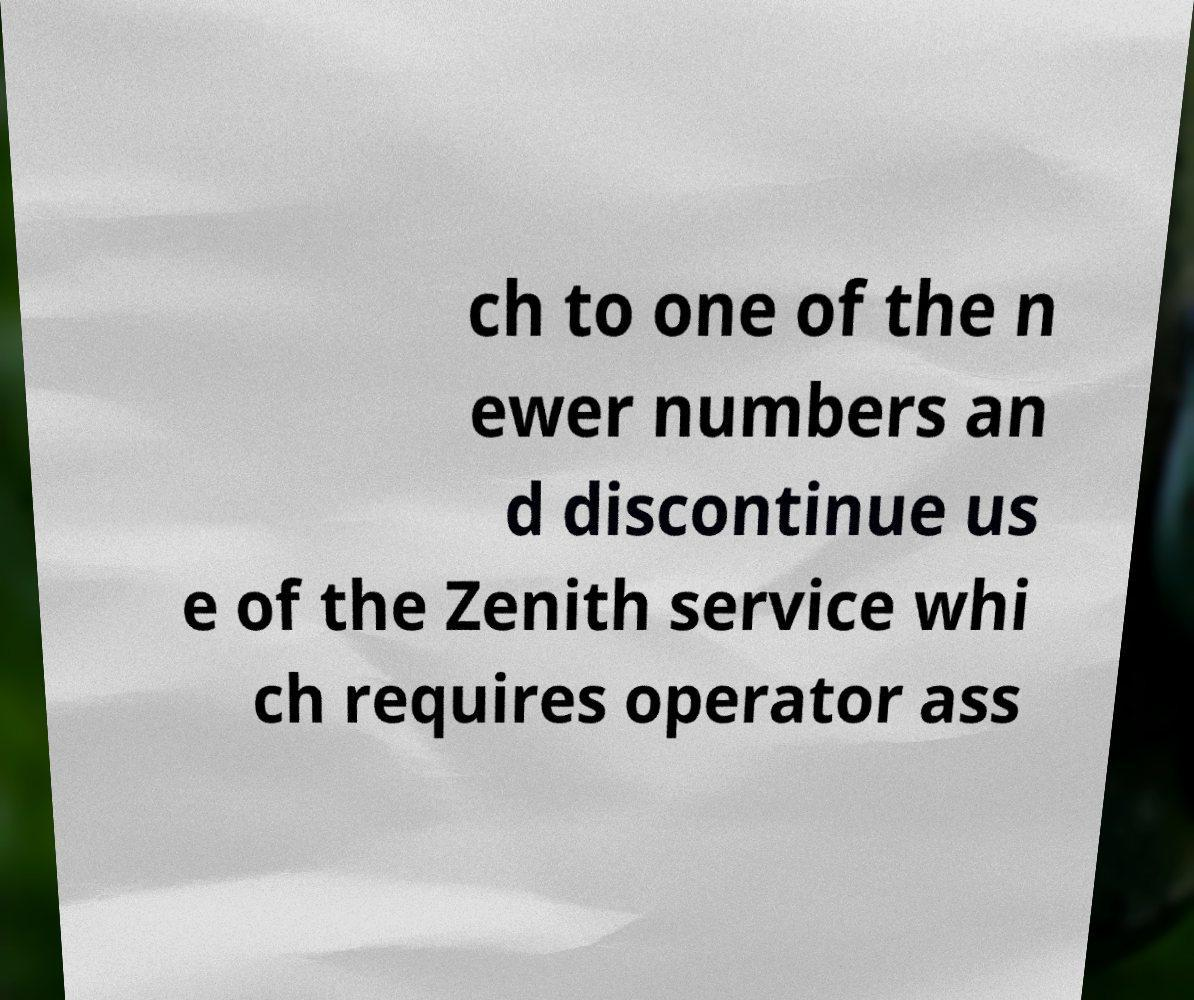What messages or text are displayed in this image? I need them in a readable, typed format. ch to one of the n ewer numbers an d discontinue us e of the Zenith service whi ch requires operator ass 